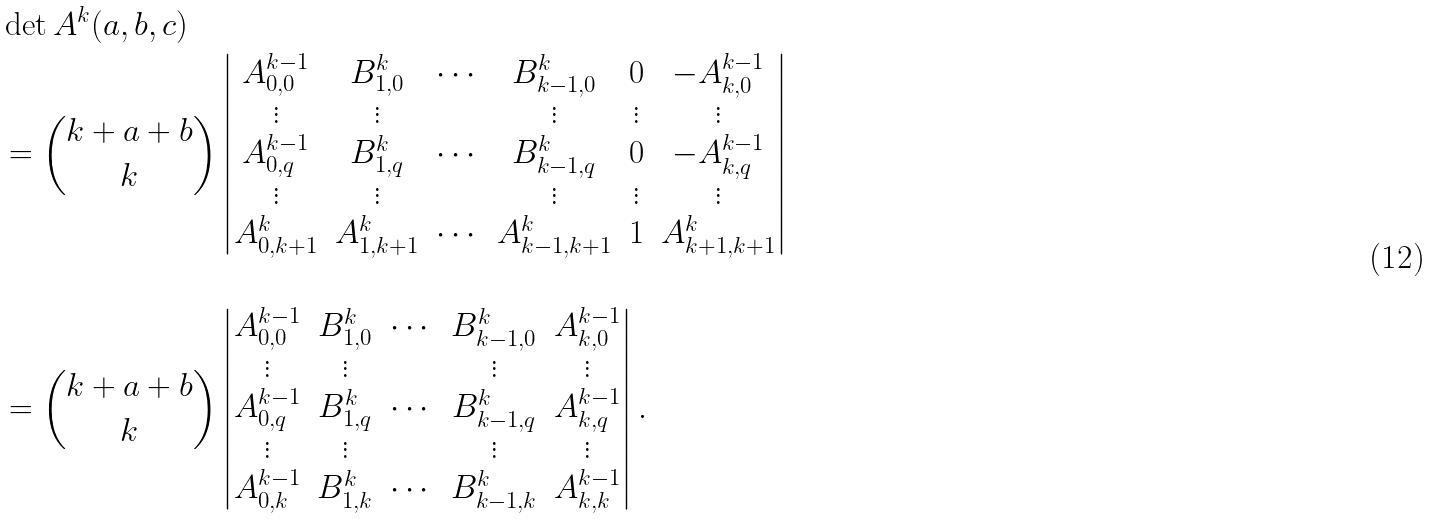<formula> <loc_0><loc_0><loc_500><loc_500>& \det A ^ { k } ( a , b , c ) \\ & = \binom { k + a + b } { k } \begin{vmatrix} A _ { 0 , 0 } ^ { k - 1 } & B _ { 1 , 0 } ^ { k } & \cdots & B _ { k - 1 , 0 } ^ { k } & 0 & - A ^ { k - 1 } _ { k , 0 } \\ \vdots & \vdots & & \vdots & \vdots & \vdots \\ A _ { 0 , q } ^ { k - 1 } & B _ { 1 , q } ^ { k } & \cdots & B ^ { k } _ { k - 1 , q } & 0 & - A ^ { k - 1 } _ { k , q } \\ \vdots & \vdots & & \vdots & \vdots & \vdots \\ A _ { 0 , k + 1 } ^ { k } & A ^ { k } _ { 1 , k + 1 } & \cdots & A ^ { k } _ { k - 1 , k + 1 } & 1 & A ^ { k } _ { k + 1 , k + 1 } \end{vmatrix} \\ & \\ & = \binom { k + a + b } { k } \begin{vmatrix} A _ { 0 , 0 } ^ { k - 1 } & B _ { 1 , 0 } ^ { k } & \cdots & B _ { k - 1 , 0 } ^ { k } & A ^ { k - 1 } _ { k , 0 } \\ \vdots & \vdots & & \vdots & \vdots \\ A _ { 0 , q } ^ { k - 1 } & B _ { 1 , q } ^ { k } & \cdots & B ^ { k } _ { k - 1 , q } & A ^ { k - 1 } _ { k , q } \\ \vdots & \vdots & & \vdots & \vdots \\ A _ { 0 , k } ^ { k - 1 } & B _ { 1 , k } ^ { k } & \cdots & B ^ { k } _ { k - 1 , k } & A ^ { k - 1 } _ { k , k } \end{vmatrix} .</formula> 